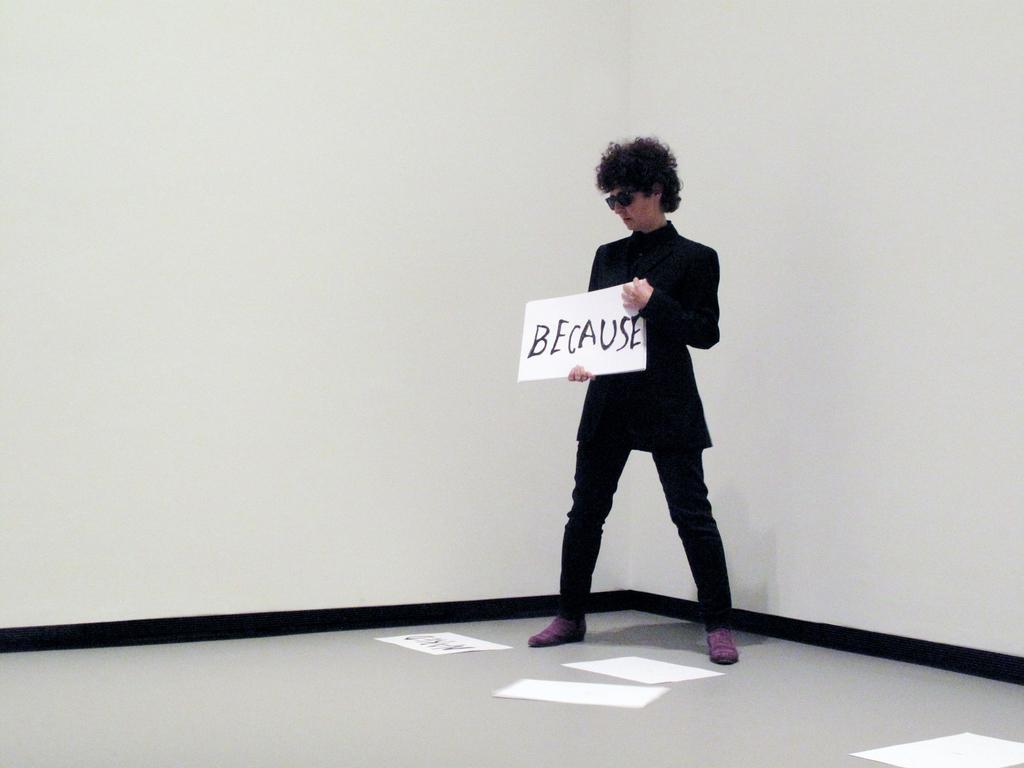What is the main subject of the picture? The main subject of the picture is a man. What is the man doing in the picture? The man is standing and holding a board in his hands. What can be seen in the background of the picture? There are white color walls and papers on the floor in the background. What type of garden can be seen in the background of the image? There is no garden present in the background of the image; it features white walls and papers on the floor. What question is the man asking in the image? The image does not show the man asking any question; he is holding a board in his hands. 